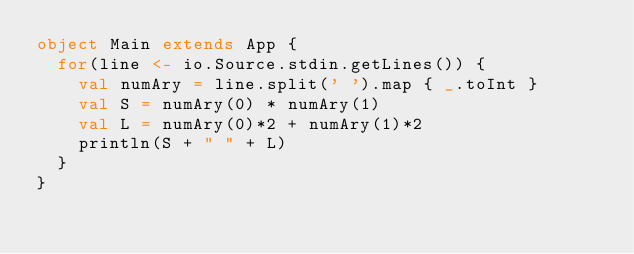Convert code to text. <code><loc_0><loc_0><loc_500><loc_500><_Scala_>object Main extends App {
  for(line <- io.Source.stdin.getLines()) {
    val numAry = line.split(' ').map { _.toInt }
    val S = numAry(0) * numAry(1)
    val L = numAry(0)*2 + numAry(1)*2
    println(S + " " + L)
  }
}
</code> 